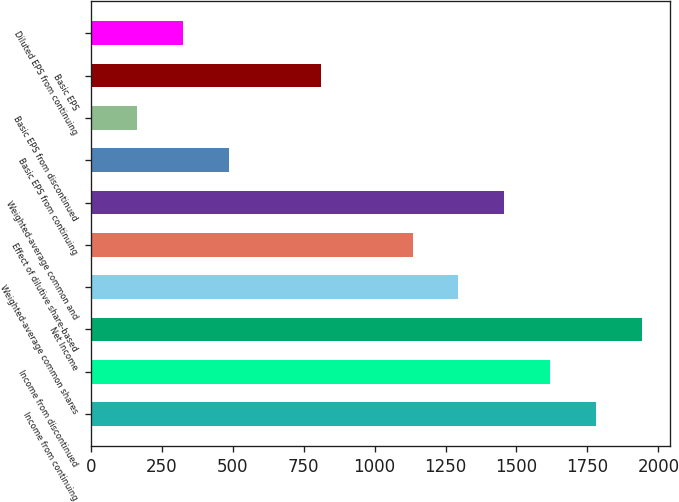Convert chart. <chart><loc_0><loc_0><loc_500><loc_500><bar_chart><fcel>Income from continuing<fcel>Income from discontinued<fcel>Net Income<fcel>Weighted-average common shares<fcel>Effect of dilutive share-based<fcel>Weighted-average common and<fcel>Basic EPS from continuing<fcel>Basic EPS from discontinued<fcel>Basic EPS<fcel>Diluted EPS from continuing<nl><fcel>1780.7<fcel>1618.96<fcel>1942.44<fcel>1295.48<fcel>1133.74<fcel>1457.22<fcel>486.78<fcel>163.3<fcel>810.26<fcel>325.04<nl></chart> 